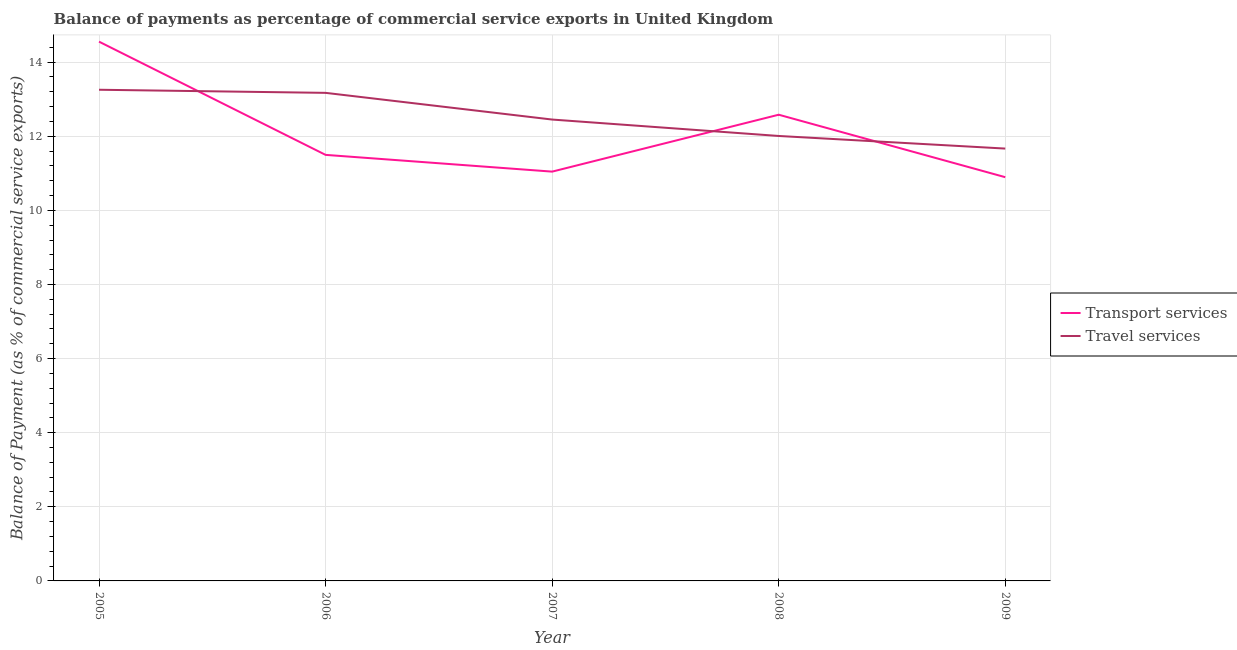How many different coloured lines are there?
Offer a very short reply. 2. Does the line corresponding to balance of payments of travel services intersect with the line corresponding to balance of payments of transport services?
Keep it short and to the point. Yes. What is the balance of payments of transport services in 2008?
Make the answer very short. 12.58. Across all years, what is the maximum balance of payments of transport services?
Provide a succinct answer. 14.55. Across all years, what is the minimum balance of payments of travel services?
Ensure brevity in your answer.  11.67. In which year was the balance of payments of travel services minimum?
Give a very brief answer. 2009. What is the total balance of payments of travel services in the graph?
Give a very brief answer. 62.55. What is the difference between the balance of payments of travel services in 2005 and that in 2007?
Provide a succinct answer. 0.8. What is the difference between the balance of payments of transport services in 2006 and the balance of payments of travel services in 2009?
Provide a short and direct response. -0.17. What is the average balance of payments of travel services per year?
Keep it short and to the point. 12.51. In the year 2007, what is the difference between the balance of payments of transport services and balance of payments of travel services?
Keep it short and to the point. -1.41. What is the ratio of the balance of payments of transport services in 2005 to that in 2006?
Offer a very short reply. 1.27. What is the difference between the highest and the second highest balance of payments of transport services?
Your answer should be very brief. 1.97. What is the difference between the highest and the lowest balance of payments of transport services?
Give a very brief answer. 3.66. In how many years, is the balance of payments of transport services greater than the average balance of payments of transport services taken over all years?
Your answer should be very brief. 2. Is the balance of payments of transport services strictly greater than the balance of payments of travel services over the years?
Provide a succinct answer. No. Is the balance of payments of travel services strictly less than the balance of payments of transport services over the years?
Offer a terse response. No. Are the values on the major ticks of Y-axis written in scientific E-notation?
Give a very brief answer. No. Does the graph contain grids?
Provide a short and direct response. Yes. How many legend labels are there?
Give a very brief answer. 2. How are the legend labels stacked?
Your response must be concise. Vertical. What is the title of the graph?
Your answer should be very brief. Balance of payments as percentage of commercial service exports in United Kingdom. Does "Highest 10% of population" appear as one of the legend labels in the graph?
Offer a very short reply. No. What is the label or title of the X-axis?
Make the answer very short. Year. What is the label or title of the Y-axis?
Offer a terse response. Balance of Payment (as % of commercial service exports). What is the Balance of Payment (as % of commercial service exports) of Transport services in 2005?
Offer a very short reply. 14.55. What is the Balance of Payment (as % of commercial service exports) in Travel services in 2005?
Ensure brevity in your answer.  13.26. What is the Balance of Payment (as % of commercial service exports) in Transport services in 2006?
Give a very brief answer. 11.5. What is the Balance of Payment (as % of commercial service exports) in Travel services in 2006?
Your answer should be compact. 13.17. What is the Balance of Payment (as % of commercial service exports) of Transport services in 2007?
Give a very brief answer. 11.05. What is the Balance of Payment (as % of commercial service exports) in Travel services in 2007?
Make the answer very short. 12.45. What is the Balance of Payment (as % of commercial service exports) in Transport services in 2008?
Keep it short and to the point. 12.58. What is the Balance of Payment (as % of commercial service exports) of Travel services in 2008?
Offer a very short reply. 12.01. What is the Balance of Payment (as % of commercial service exports) of Transport services in 2009?
Your answer should be compact. 10.9. What is the Balance of Payment (as % of commercial service exports) of Travel services in 2009?
Provide a short and direct response. 11.67. Across all years, what is the maximum Balance of Payment (as % of commercial service exports) of Transport services?
Give a very brief answer. 14.55. Across all years, what is the maximum Balance of Payment (as % of commercial service exports) of Travel services?
Provide a succinct answer. 13.26. Across all years, what is the minimum Balance of Payment (as % of commercial service exports) of Transport services?
Make the answer very short. 10.9. Across all years, what is the minimum Balance of Payment (as % of commercial service exports) of Travel services?
Your answer should be very brief. 11.67. What is the total Balance of Payment (as % of commercial service exports) in Transport services in the graph?
Provide a short and direct response. 60.57. What is the total Balance of Payment (as % of commercial service exports) in Travel services in the graph?
Provide a short and direct response. 62.55. What is the difference between the Balance of Payment (as % of commercial service exports) in Transport services in 2005 and that in 2006?
Your response must be concise. 3.06. What is the difference between the Balance of Payment (as % of commercial service exports) of Travel services in 2005 and that in 2006?
Provide a short and direct response. 0.08. What is the difference between the Balance of Payment (as % of commercial service exports) in Transport services in 2005 and that in 2007?
Ensure brevity in your answer.  3.51. What is the difference between the Balance of Payment (as % of commercial service exports) of Travel services in 2005 and that in 2007?
Your response must be concise. 0.8. What is the difference between the Balance of Payment (as % of commercial service exports) in Transport services in 2005 and that in 2008?
Offer a terse response. 1.97. What is the difference between the Balance of Payment (as % of commercial service exports) in Travel services in 2005 and that in 2008?
Keep it short and to the point. 1.25. What is the difference between the Balance of Payment (as % of commercial service exports) of Transport services in 2005 and that in 2009?
Keep it short and to the point. 3.66. What is the difference between the Balance of Payment (as % of commercial service exports) of Travel services in 2005 and that in 2009?
Provide a short and direct response. 1.59. What is the difference between the Balance of Payment (as % of commercial service exports) in Transport services in 2006 and that in 2007?
Your answer should be very brief. 0.45. What is the difference between the Balance of Payment (as % of commercial service exports) in Travel services in 2006 and that in 2007?
Your answer should be very brief. 0.72. What is the difference between the Balance of Payment (as % of commercial service exports) of Transport services in 2006 and that in 2008?
Your response must be concise. -1.08. What is the difference between the Balance of Payment (as % of commercial service exports) in Travel services in 2006 and that in 2008?
Ensure brevity in your answer.  1.16. What is the difference between the Balance of Payment (as % of commercial service exports) of Transport services in 2006 and that in 2009?
Your answer should be compact. 0.6. What is the difference between the Balance of Payment (as % of commercial service exports) in Travel services in 2006 and that in 2009?
Provide a succinct answer. 1.5. What is the difference between the Balance of Payment (as % of commercial service exports) of Transport services in 2007 and that in 2008?
Your response must be concise. -1.54. What is the difference between the Balance of Payment (as % of commercial service exports) in Travel services in 2007 and that in 2008?
Offer a terse response. 0.44. What is the difference between the Balance of Payment (as % of commercial service exports) of Transport services in 2007 and that in 2009?
Your answer should be compact. 0.15. What is the difference between the Balance of Payment (as % of commercial service exports) in Travel services in 2007 and that in 2009?
Offer a terse response. 0.78. What is the difference between the Balance of Payment (as % of commercial service exports) in Transport services in 2008 and that in 2009?
Your response must be concise. 1.69. What is the difference between the Balance of Payment (as % of commercial service exports) of Travel services in 2008 and that in 2009?
Offer a very short reply. 0.34. What is the difference between the Balance of Payment (as % of commercial service exports) of Transport services in 2005 and the Balance of Payment (as % of commercial service exports) of Travel services in 2006?
Your answer should be very brief. 1.38. What is the difference between the Balance of Payment (as % of commercial service exports) in Transport services in 2005 and the Balance of Payment (as % of commercial service exports) in Travel services in 2007?
Keep it short and to the point. 2.1. What is the difference between the Balance of Payment (as % of commercial service exports) of Transport services in 2005 and the Balance of Payment (as % of commercial service exports) of Travel services in 2008?
Ensure brevity in your answer.  2.55. What is the difference between the Balance of Payment (as % of commercial service exports) in Transport services in 2005 and the Balance of Payment (as % of commercial service exports) in Travel services in 2009?
Give a very brief answer. 2.89. What is the difference between the Balance of Payment (as % of commercial service exports) in Transport services in 2006 and the Balance of Payment (as % of commercial service exports) in Travel services in 2007?
Offer a very short reply. -0.95. What is the difference between the Balance of Payment (as % of commercial service exports) of Transport services in 2006 and the Balance of Payment (as % of commercial service exports) of Travel services in 2008?
Your answer should be very brief. -0.51. What is the difference between the Balance of Payment (as % of commercial service exports) in Transport services in 2006 and the Balance of Payment (as % of commercial service exports) in Travel services in 2009?
Provide a succinct answer. -0.17. What is the difference between the Balance of Payment (as % of commercial service exports) in Transport services in 2007 and the Balance of Payment (as % of commercial service exports) in Travel services in 2008?
Offer a very short reply. -0.96. What is the difference between the Balance of Payment (as % of commercial service exports) in Transport services in 2007 and the Balance of Payment (as % of commercial service exports) in Travel services in 2009?
Offer a very short reply. -0.62. What is the difference between the Balance of Payment (as % of commercial service exports) of Transport services in 2008 and the Balance of Payment (as % of commercial service exports) of Travel services in 2009?
Provide a succinct answer. 0.91. What is the average Balance of Payment (as % of commercial service exports) of Transport services per year?
Provide a short and direct response. 12.11. What is the average Balance of Payment (as % of commercial service exports) of Travel services per year?
Make the answer very short. 12.51. In the year 2005, what is the difference between the Balance of Payment (as % of commercial service exports) in Transport services and Balance of Payment (as % of commercial service exports) in Travel services?
Keep it short and to the point. 1.3. In the year 2006, what is the difference between the Balance of Payment (as % of commercial service exports) of Transport services and Balance of Payment (as % of commercial service exports) of Travel services?
Offer a very short reply. -1.67. In the year 2007, what is the difference between the Balance of Payment (as % of commercial service exports) of Transport services and Balance of Payment (as % of commercial service exports) of Travel services?
Provide a short and direct response. -1.41. In the year 2008, what is the difference between the Balance of Payment (as % of commercial service exports) in Transport services and Balance of Payment (as % of commercial service exports) in Travel services?
Your answer should be compact. 0.57. In the year 2009, what is the difference between the Balance of Payment (as % of commercial service exports) in Transport services and Balance of Payment (as % of commercial service exports) in Travel services?
Provide a succinct answer. -0.77. What is the ratio of the Balance of Payment (as % of commercial service exports) in Transport services in 2005 to that in 2006?
Offer a very short reply. 1.27. What is the ratio of the Balance of Payment (as % of commercial service exports) of Travel services in 2005 to that in 2006?
Your response must be concise. 1.01. What is the ratio of the Balance of Payment (as % of commercial service exports) in Transport services in 2005 to that in 2007?
Provide a short and direct response. 1.32. What is the ratio of the Balance of Payment (as % of commercial service exports) in Travel services in 2005 to that in 2007?
Provide a succinct answer. 1.06. What is the ratio of the Balance of Payment (as % of commercial service exports) of Transport services in 2005 to that in 2008?
Make the answer very short. 1.16. What is the ratio of the Balance of Payment (as % of commercial service exports) of Travel services in 2005 to that in 2008?
Your response must be concise. 1.1. What is the ratio of the Balance of Payment (as % of commercial service exports) of Transport services in 2005 to that in 2009?
Offer a terse response. 1.34. What is the ratio of the Balance of Payment (as % of commercial service exports) in Travel services in 2005 to that in 2009?
Ensure brevity in your answer.  1.14. What is the ratio of the Balance of Payment (as % of commercial service exports) of Transport services in 2006 to that in 2007?
Keep it short and to the point. 1.04. What is the ratio of the Balance of Payment (as % of commercial service exports) of Travel services in 2006 to that in 2007?
Give a very brief answer. 1.06. What is the ratio of the Balance of Payment (as % of commercial service exports) in Transport services in 2006 to that in 2008?
Keep it short and to the point. 0.91. What is the ratio of the Balance of Payment (as % of commercial service exports) of Travel services in 2006 to that in 2008?
Offer a terse response. 1.1. What is the ratio of the Balance of Payment (as % of commercial service exports) of Transport services in 2006 to that in 2009?
Your answer should be very brief. 1.06. What is the ratio of the Balance of Payment (as % of commercial service exports) of Travel services in 2006 to that in 2009?
Your answer should be compact. 1.13. What is the ratio of the Balance of Payment (as % of commercial service exports) of Transport services in 2007 to that in 2008?
Give a very brief answer. 0.88. What is the ratio of the Balance of Payment (as % of commercial service exports) of Travel services in 2007 to that in 2008?
Keep it short and to the point. 1.04. What is the ratio of the Balance of Payment (as % of commercial service exports) in Transport services in 2007 to that in 2009?
Provide a short and direct response. 1.01. What is the ratio of the Balance of Payment (as % of commercial service exports) in Travel services in 2007 to that in 2009?
Ensure brevity in your answer.  1.07. What is the ratio of the Balance of Payment (as % of commercial service exports) in Transport services in 2008 to that in 2009?
Keep it short and to the point. 1.15. What is the ratio of the Balance of Payment (as % of commercial service exports) in Travel services in 2008 to that in 2009?
Your answer should be very brief. 1.03. What is the difference between the highest and the second highest Balance of Payment (as % of commercial service exports) of Transport services?
Provide a short and direct response. 1.97. What is the difference between the highest and the second highest Balance of Payment (as % of commercial service exports) in Travel services?
Ensure brevity in your answer.  0.08. What is the difference between the highest and the lowest Balance of Payment (as % of commercial service exports) of Transport services?
Make the answer very short. 3.66. What is the difference between the highest and the lowest Balance of Payment (as % of commercial service exports) in Travel services?
Provide a succinct answer. 1.59. 